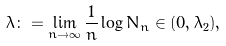<formula> <loc_0><loc_0><loc_500><loc_500>\lambda \colon = \lim _ { n \to \infty } \frac { 1 } { n } \log N _ { n } \in ( 0 , \lambda _ { 2 } ) ,</formula> 